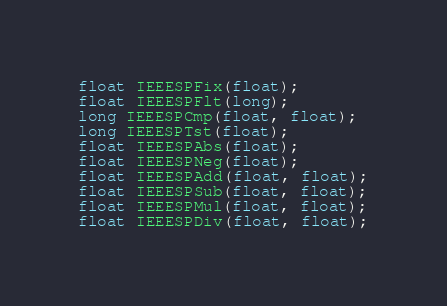Convert code to text. <code><loc_0><loc_0><loc_500><loc_500><_C_>float IEEESPFix(float);
float IEEESPFlt(long);
long IEEESPCmp(float, float);
long IEEESPTst(float);
float IEEESPAbs(float);
float IEEESPNeg(float);
float IEEESPAdd(float, float);
float IEEESPSub(float, float);
float IEEESPMul(float, float);
float IEEESPDiv(float, float);
</code> 